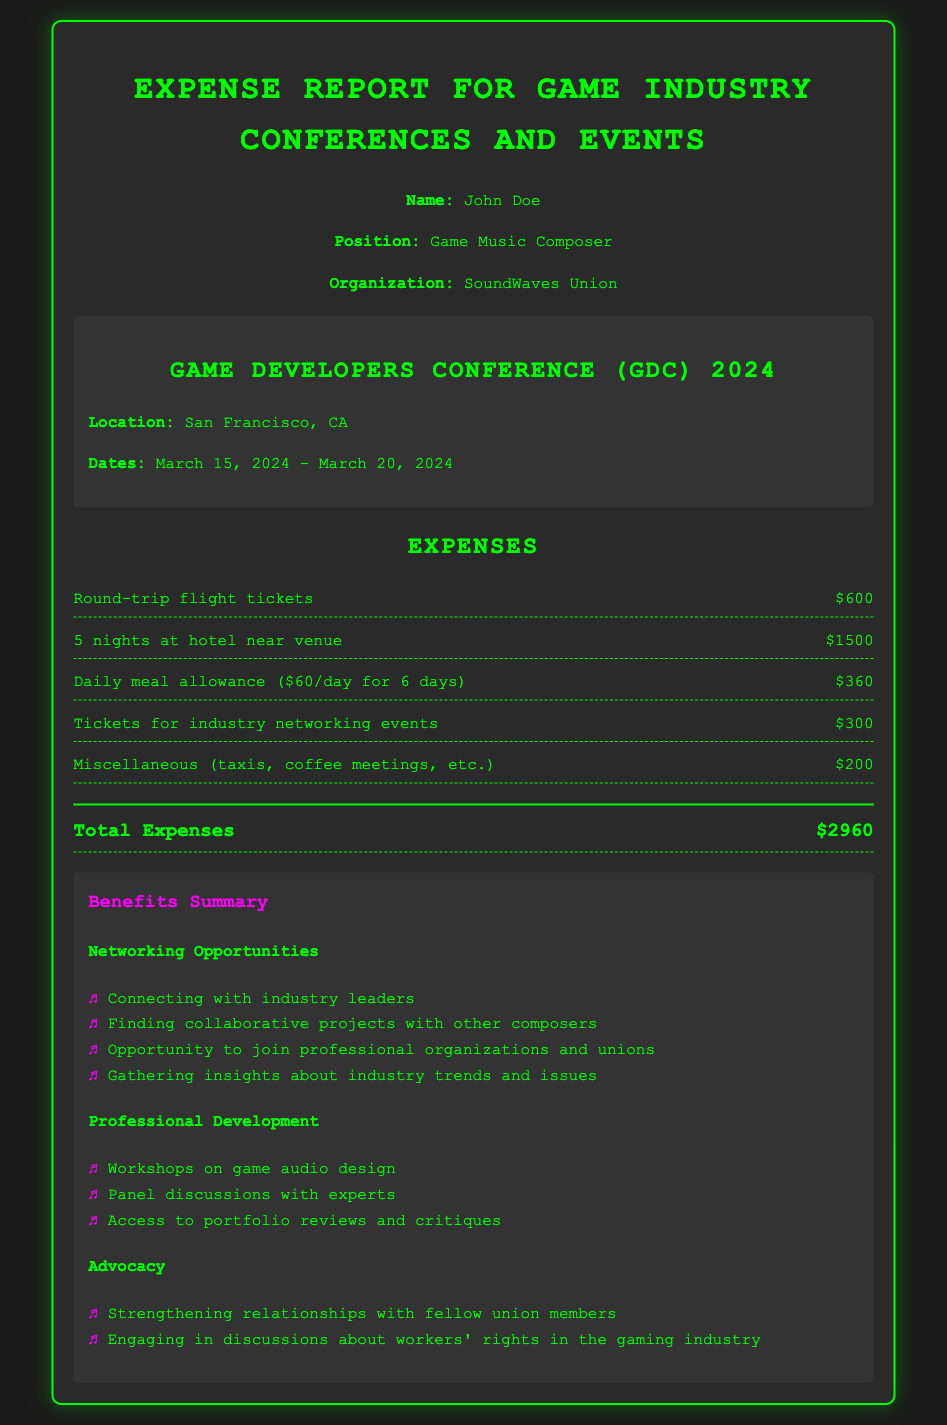What is the total expense for the trip? The total expense is the sum of all individual expenses listed, which amounts to $600 + $1500 + $360 + $300 + $200 = $2960.
Answer: $2960 How many nights is the hotel accommodation for? The hotel accommodation is for the duration specified, which is 5 nights.
Answer: 5 nights What is the daily meal allowance? The daily meal allowance is stated in the document as $60 per day.
Answer: $60 What event is mentioned in the document? The event mentioned in the document is the Game Developers Conference (GDC) 2024.
Answer: Game Developers Conference (GDC) 2024 Which organization does the traveler represent? The traveler represents the organization named in the document, which is SoundWaves Union.
Answer: SoundWaves Union What date does the conference start? The conference starts on the date specified, which is March 15, 2024.
Answer: March 15, 2024 What is one benefit of attending the conference? One benefit mentioned for attending the conference is connecting with industry leaders.
Answer: Connecting with industry leaders How much was spent on tickets for networking events? The amount specified for networking event tickets in the document is $300.
Answer: $300 What type of professionals can join discussions about workers' rights? The document mentions fellow union members as the individuals engaging in discussions about workers' rights.
Answer: Fellow union members 